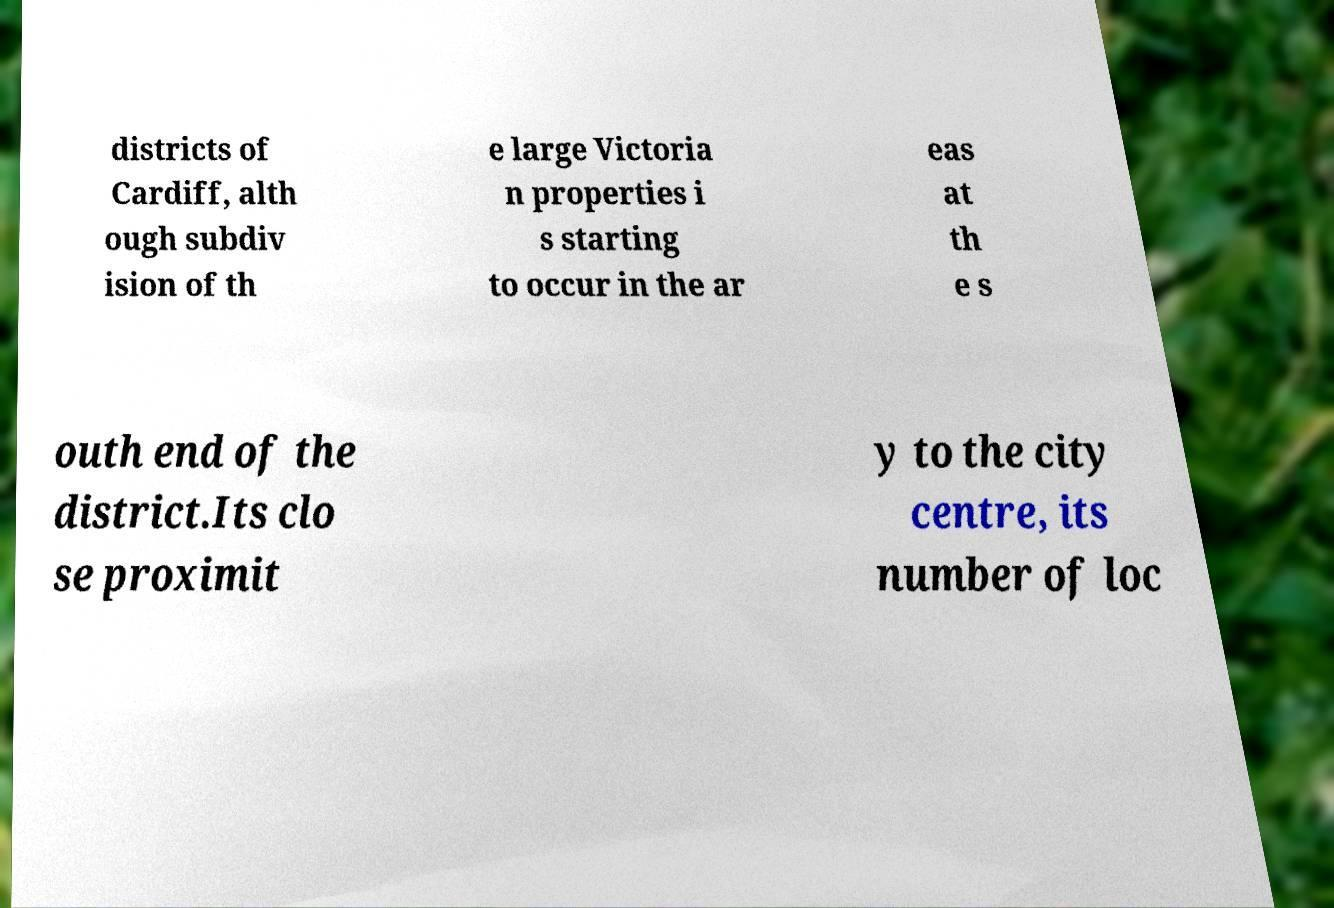Can you read and provide the text displayed in the image?This photo seems to have some interesting text. Can you extract and type it out for me? districts of Cardiff, alth ough subdiv ision of th e large Victoria n properties i s starting to occur in the ar eas at th e s outh end of the district.Its clo se proximit y to the city centre, its number of loc 